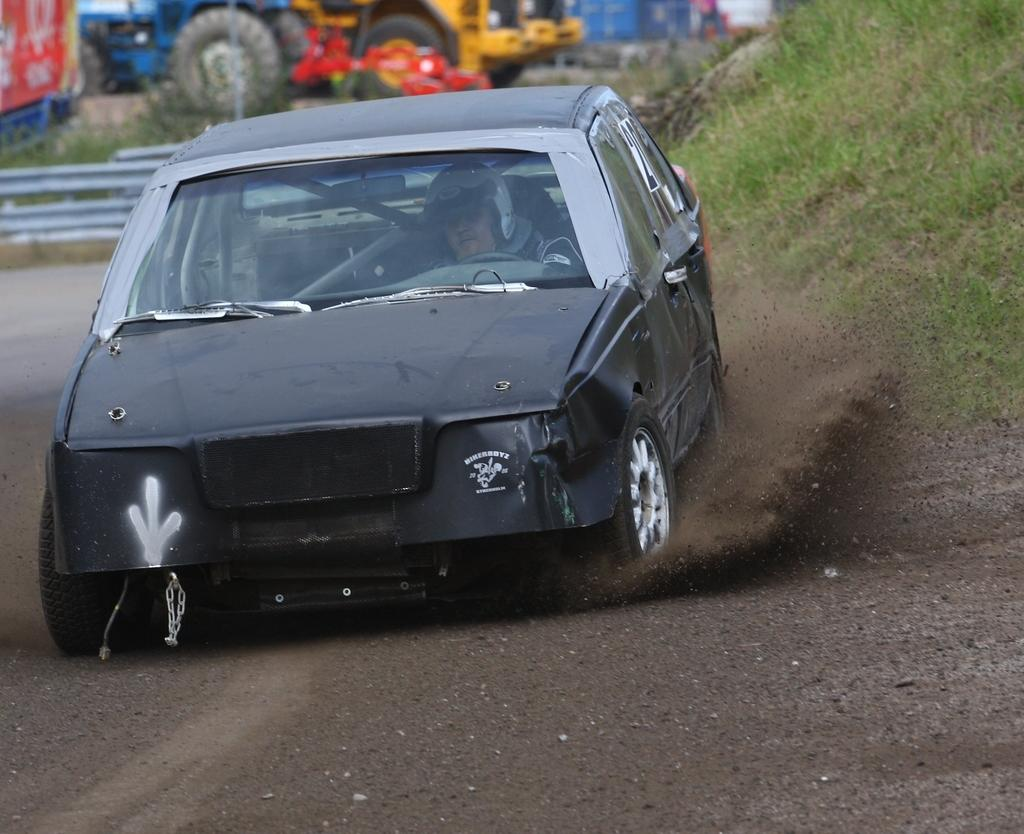What is the main subject of the image? There is a vehicle in the image. Who or what is inside the vehicle? A person is inside the vehicle. Where is the vehicle located? The vehicle is on the road. What can be seen in the background of the image? There is grass, plants, other vehicles, and some objects visible in the background. What type of scene is being depicted with the pigs and fowl in the image? There are no pigs or fowl present in the image; it features a vehicle on the road with a person inside and a background containing grass, plants, other vehicles, and objects. 